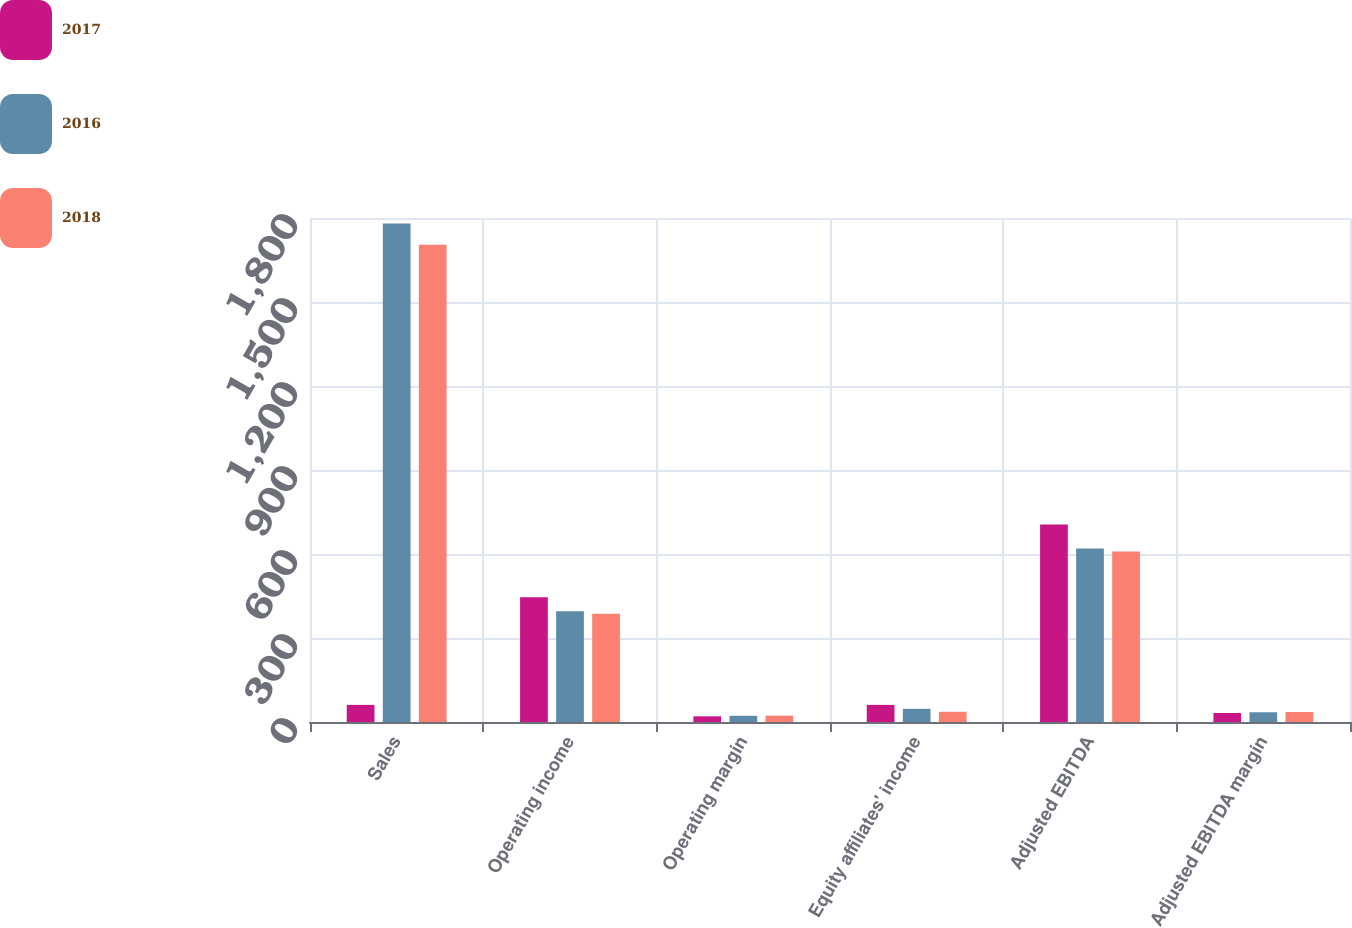Convert chart. <chart><loc_0><loc_0><loc_500><loc_500><stacked_bar_chart><ecel><fcel>Sales<fcel>Operating income<fcel>Operating margin<fcel>Equity affiliates' income<fcel>Adjusted EBITDA<fcel>Adjusted EBITDA margin<nl><fcel>2017<fcel>61.1<fcel>445.8<fcel>20.3<fcel>61.1<fcel>705.5<fcel>32.2<nl><fcel>2016<fcel>1780.4<fcel>395.5<fcel>22.2<fcel>47.1<fcel>619.7<fcel>34.8<nl><fcel>2018<fcel>1704.4<fcel>387<fcel>22.7<fcel>36.5<fcel>609.2<fcel>35.7<nl></chart> 